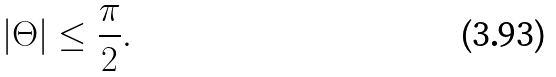<formula> <loc_0><loc_0><loc_500><loc_500>| \Theta | \leq \frac { \pi } { 2 } .</formula> 